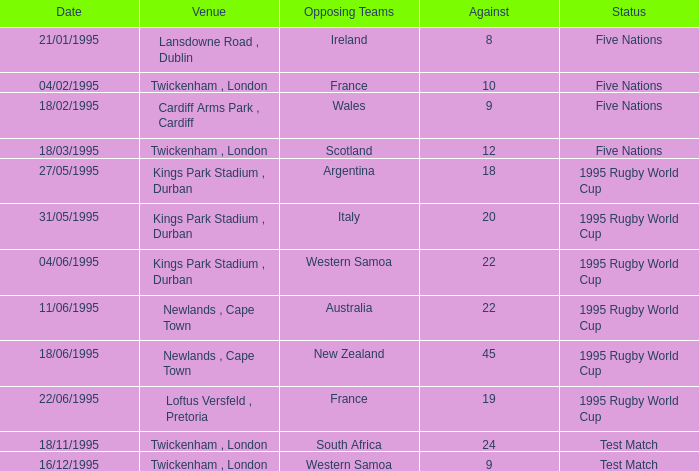What date has a status of 1995 rugby world cup and an against of 20? 31/05/1995. 